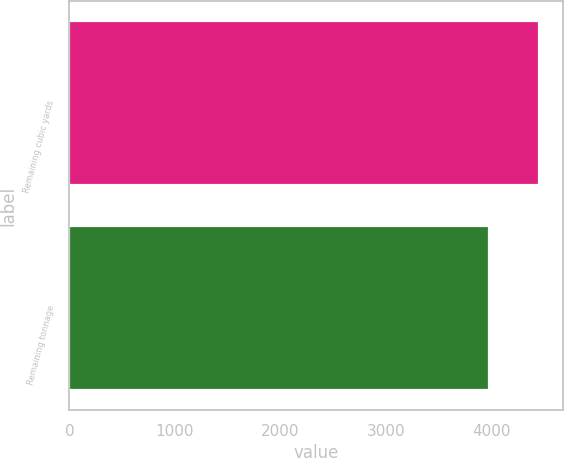<chart> <loc_0><loc_0><loc_500><loc_500><bar_chart><fcel>Remaining cubic yards<fcel>Remaining tonnage<nl><fcel>4456<fcel>3979<nl></chart> 